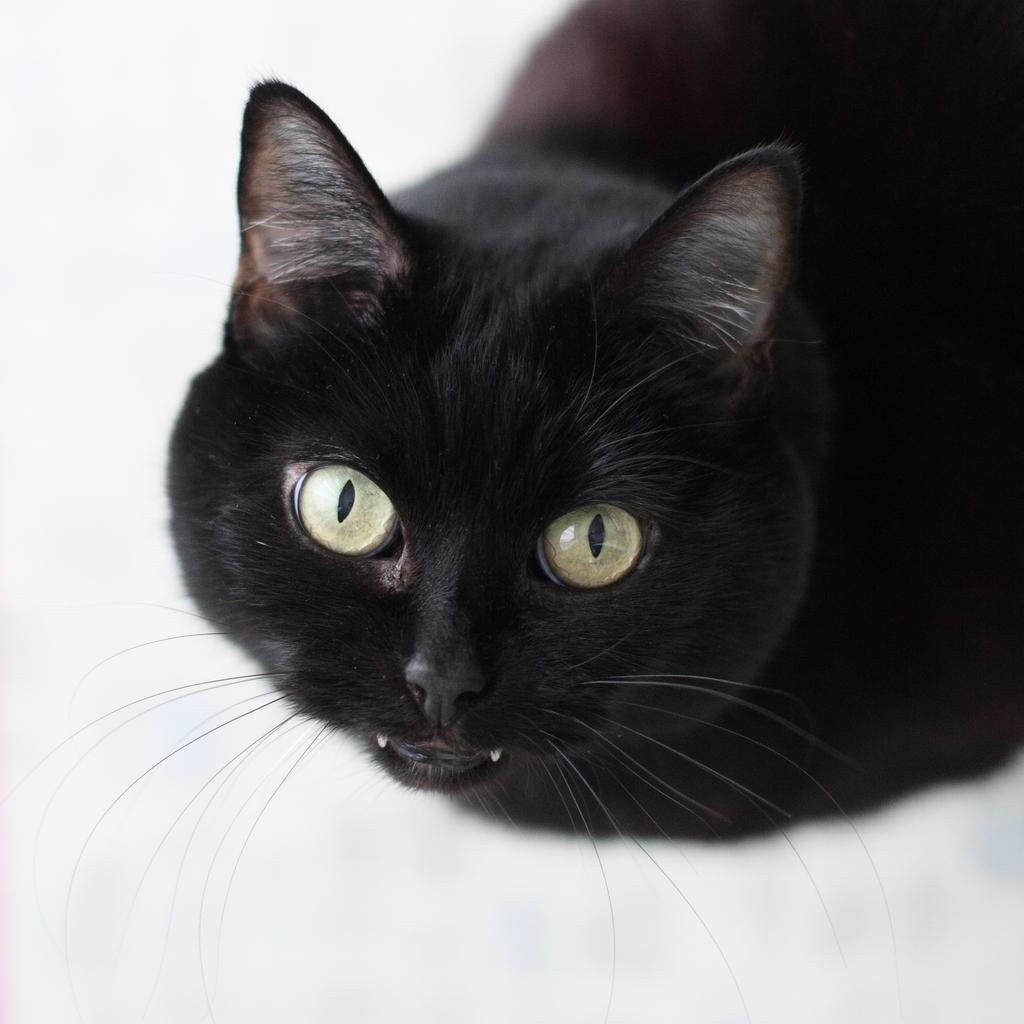Can you describe this image briefly? In this image I can see white colour surface and on it I can see a black colour cat. 